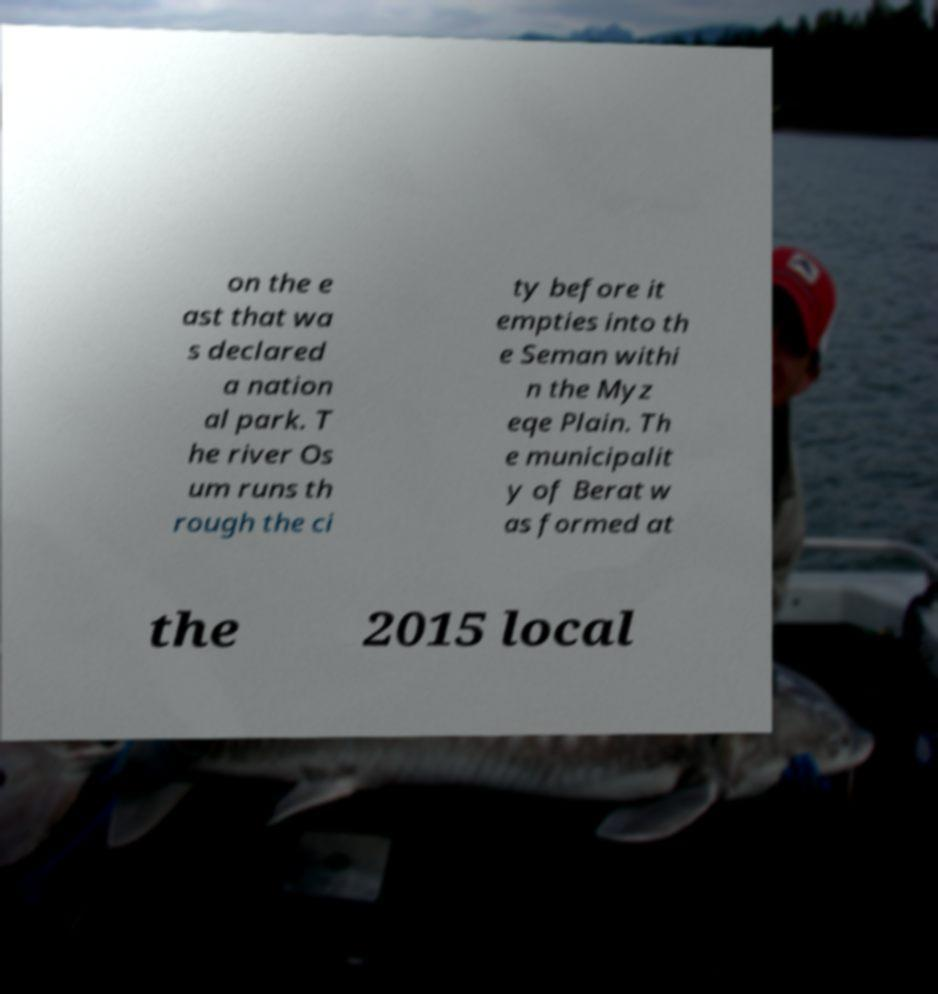Please read and relay the text visible in this image. What does it say? on the e ast that wa s declared a nation al park. T he river Os um runs th rough the ci ty before it empties into th e Seman withi n the Myz eqe Plain. Th e municipalit y of Berat w as formed at the 2015 local 